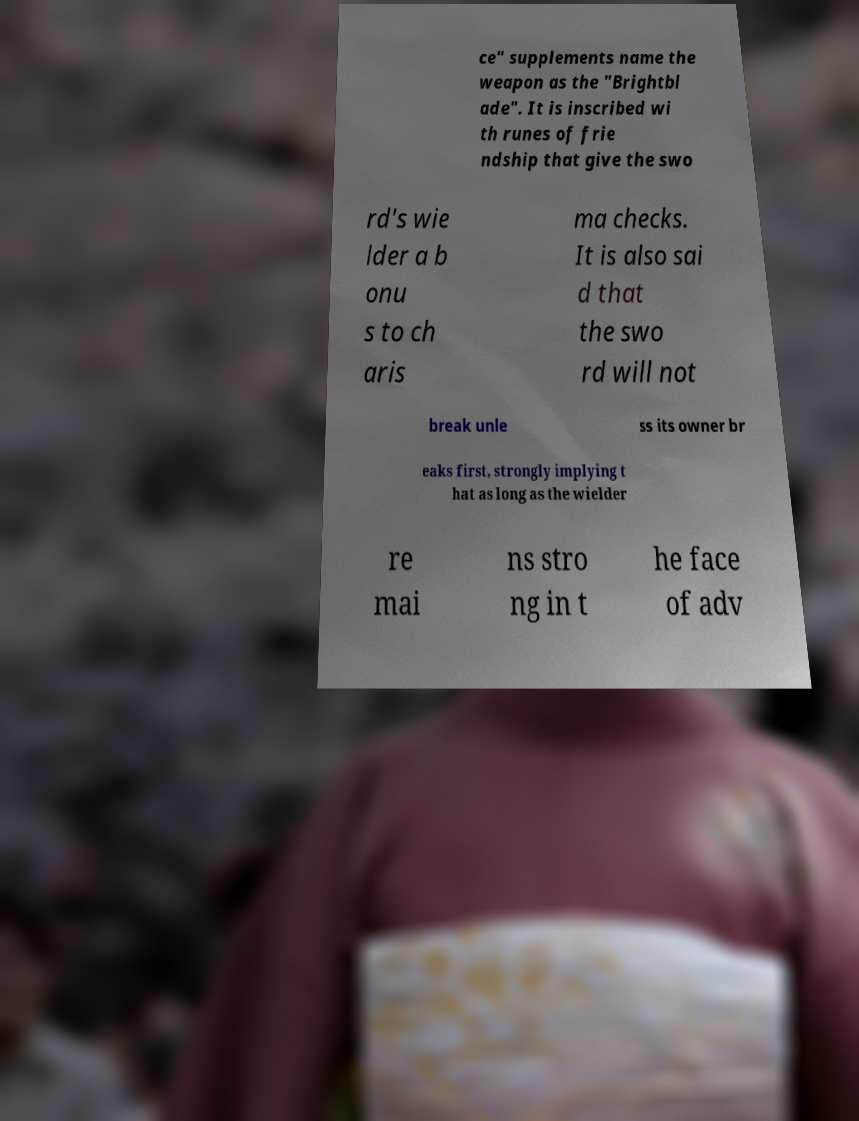What messages or text are displayed in this image? I need them in a readable, typed format. ce" supplements name the weapon as the "Brightbl ade". It is inscribed wi th runes of frie ndship that give the swo rd's wie lder a b onu s to ch aris ma checks. It is also sai d that the swo rd will not break unle ss its owner br eaks first, strongly implying t hat as long as the wielder re mai ns stro ng in t he face of adv 